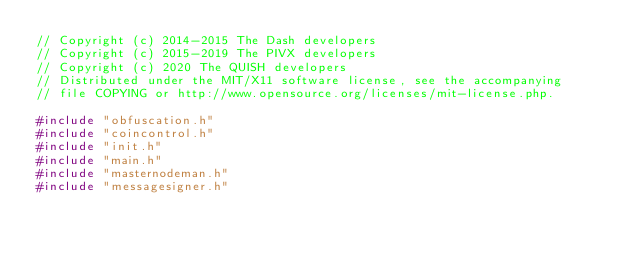Convert code to text. <code><loc_0><loc_0><loc_500><loc_500><_C++_>// Copyright (c) 2014-2015 The Dash developers
// Copyright (c) 2015-2019 The PIVX developers
// Copyright (c) 2020 The QUISH developers
// Distributed under the MIT/X11 software license, see the accompanying
// file COPYING or http://www.opensource.org/licenses/mit-license.php.

#include "obfuscation.h"
#include "coincontrol.h"
#include "init.h"
#include "main.h"
#include "masternodeman.h"
#include "messagesigner.h"</code> 